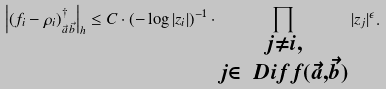Convert formula to latex. <formula><loc_0><loc_0><loc_500><loc_500>\left | ( f _ { i } - \rho _ { i } ) ^ { \dagger } _ { \vec { a } \, \vec { b } } \right | _ { h } \leq C \cdot ( - \log | z _ { i } | ) ^ { - 1 } \cdot \prod _ { \substack { j \neq i , \\ j \in \ D i f f ( \vec { a } , \vec { b } ) } } | z _ { j } | ^ { \epsilon } .</formula> 